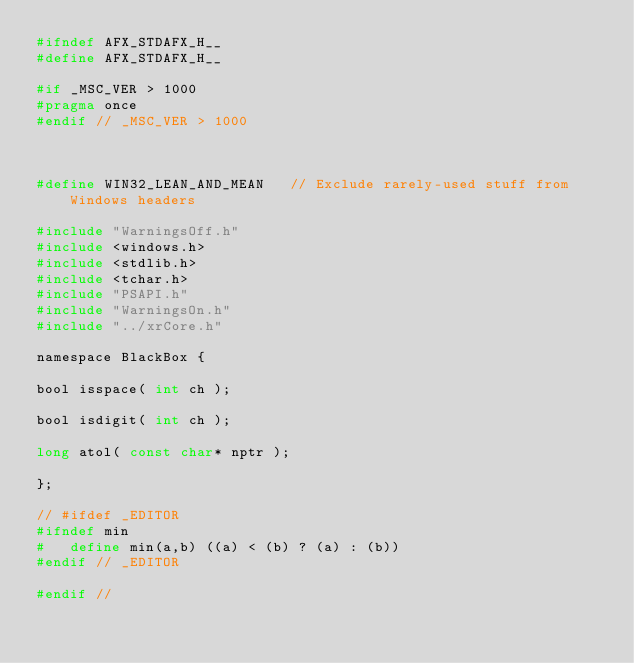<code> <loc_0><loc_0><loc_500><loc_500><_C_>#ifndef AFX_STDAFX_H__
#define AFX_STDAFX_H__

#if _MSC_VER > 1000
#pragma once
#endif // _MSC_VER > 1000



#define WIN32_LEAN_AND_MEAN		// Exclude rarely-used stuff from Windows headers

#include "WarningsOff.h"
#include <windows.h>
#include <stdlib.h>
#include <tchar.h>
#include "PSAPI.h"
#include "WarningsOn.h"
#include "../xrCore.h"

namespace BlackBox {

bool isspace( int ch ); 

bool isdigit( int ch );

long atol( const char* nptr );

};

// #ifdef _EDITOR
#ifndef min
#   define min(a,b) ((a) < (b) ? (a) : (b))
#endif // _EDITOR

#endif //
</code> 